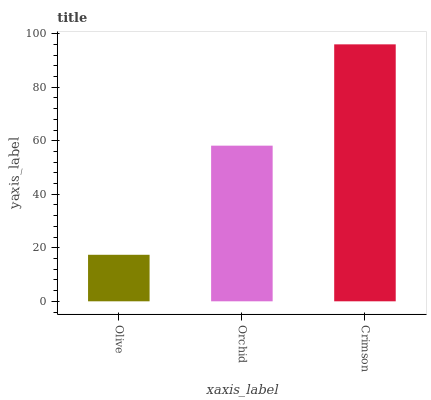Is Olive the minimum?
Answer yes or no. Yes. Is Crimson the maximum?
Answer yes or no. Yes. Is Orchid the minimum?
Answer yes or no. No. Is Orchid the maximum?
Answer yes or no. No. Is Orchid greater than Olive?
Answer yes or no. Yes. Is Olive less than Orchid?
Answer yes or no. Yes. Is Olive greater than Orchid?
Answer yes or no. No. Is Orchid less than Olive?
Answer yes or no. No. Is Orchid the high median?
Answer yes or no. Yes. Is Orchid the low median?
Answer yes or no. Yes. Is Crimson the high median?
Answer yes or no. No. Is Olive the low median?
Answer yes or no. No. 